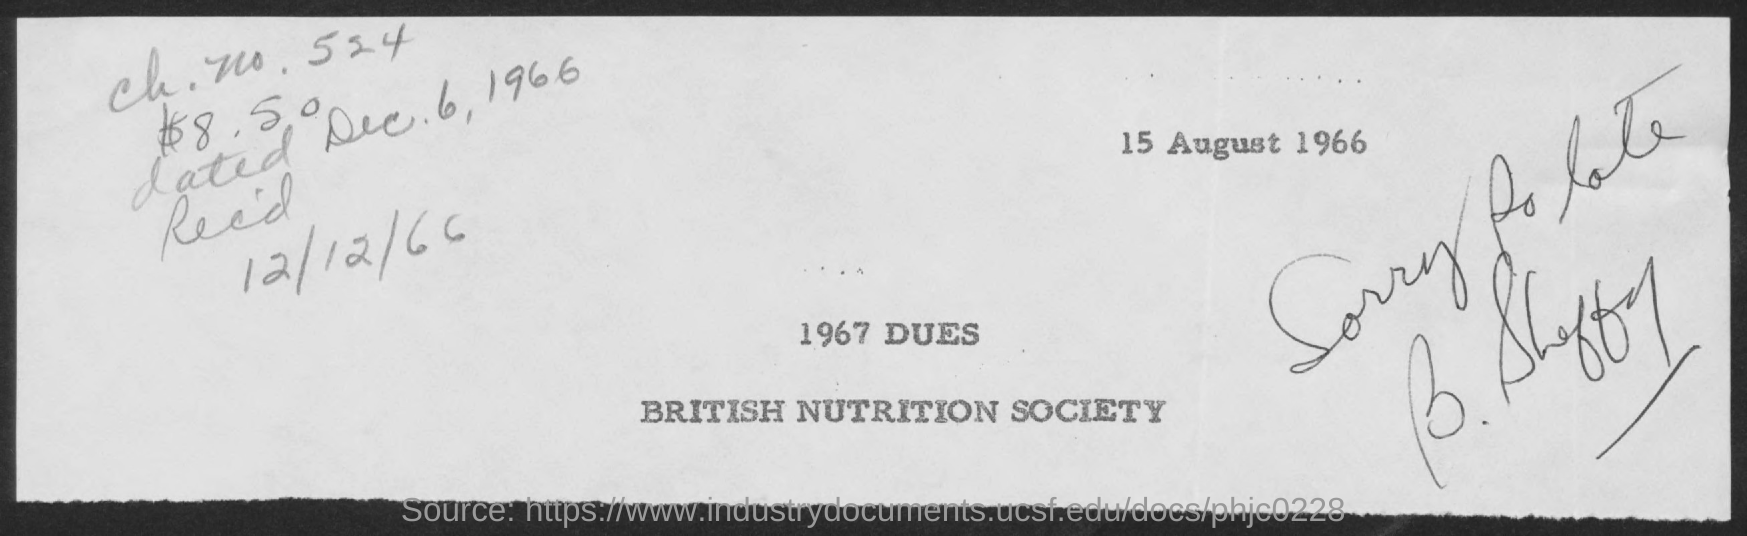What is the received date given in this document?
Provide a succinct answer. 12/12/66. 